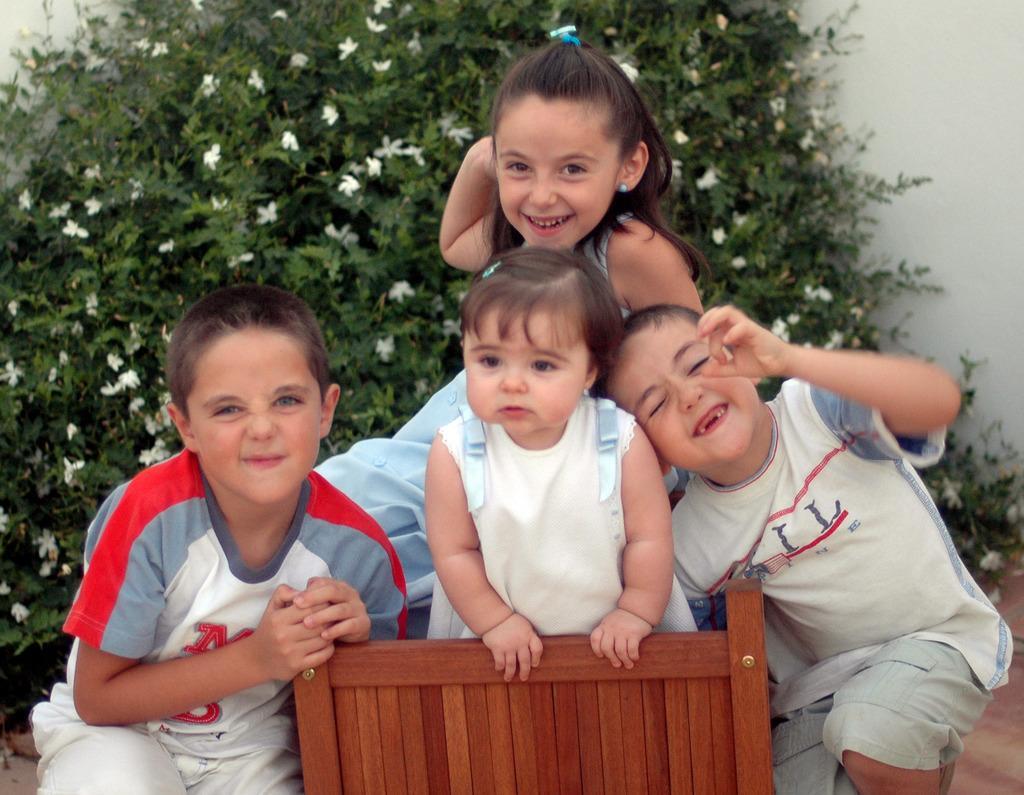In one or two sentences, can you explain what this image depicts? In this image there are a few children with smile on their face, in front of them there is a wooden structure, behind them there is a plant and trees. In the background there is a wall. 